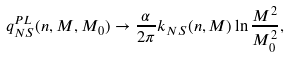<formula> <loc_0><loc_0><loc_500><loc_500>q _ { N S } ^ { P L } ( n , M , M _ { 0 } ) \rightarrow \frac { \alpha } { 2 \pi } k _ { N S } ( n , M ) \ln \frac { M ^ { 2 } } { M _ { 0 } ^ { 2 } } ,</formula> 